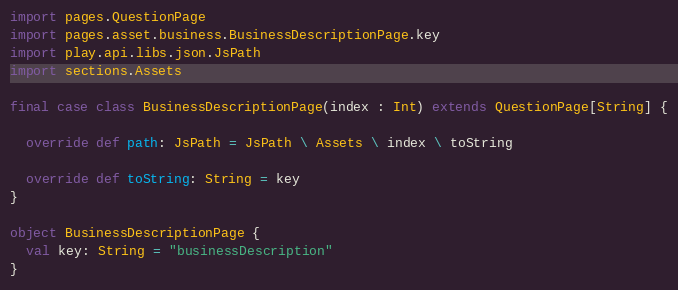Convert code to text. <code><loc_0><loc_0><loc_500><loc_500><_Scala_>
import pages.QuestionPage
import pages.asset.business.BusinessDescriptionPage.key
import play.api.libs.json.JsPath
import sections.Assets

final case class BusinessDescriptionPage(index : Int) extends QuestionPage[String] {

  override def path: JsPath = JsPath \ Assets \ index \ toString

  override def toString: String = key
}

object BusinessDescriptionPage {
  val key: String = "businessDescription"
}
</code> 